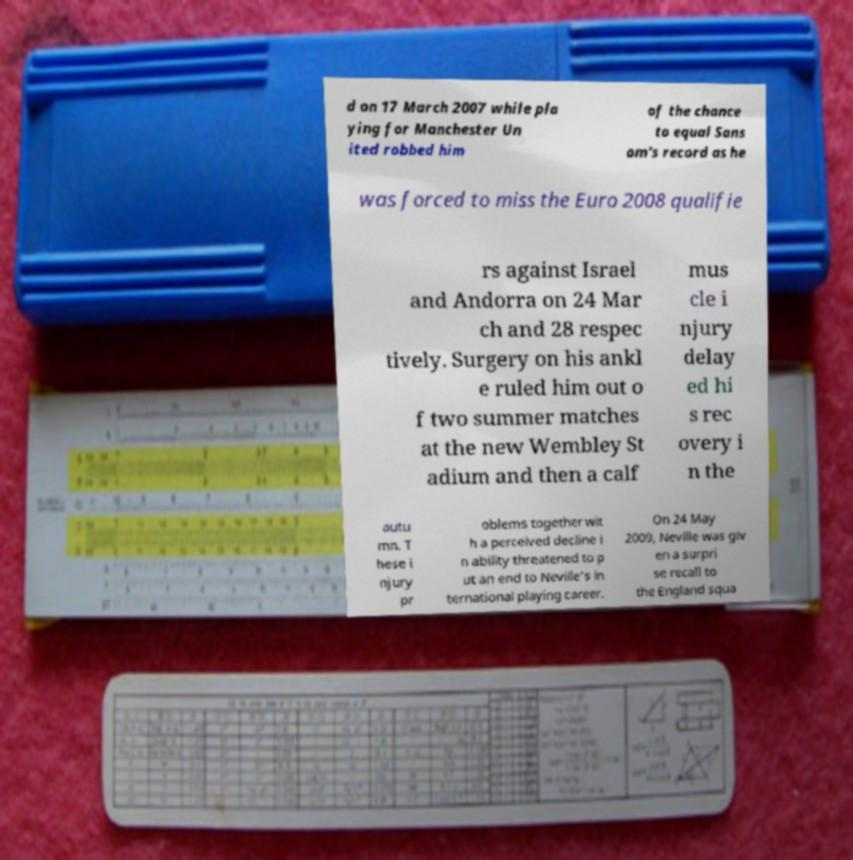For documentation purposes, I need the text within this image transcribed. Could you provide that? d on 17 March 2007 while pla ying for Manchester Un ited robbed him of the chance to equal Sans om's record as he was forced to miss the Euro 2008 qualifie rs against Israel and Andorra on 24 Mar ch and 28 respec tively. Surgery on his ankl e ruled him out o f two summer matches at the new Wembley St adium and then a calf mus cle i njury delay ed hi s rec overy i n the autu mn. T hese i njury pr oblems together wit h a perceived decline i n ability threatened to p ut an end to Neville's in ternational playing career. On 24 May 2009, Neville was giv en a surpri se recall to the England squa 